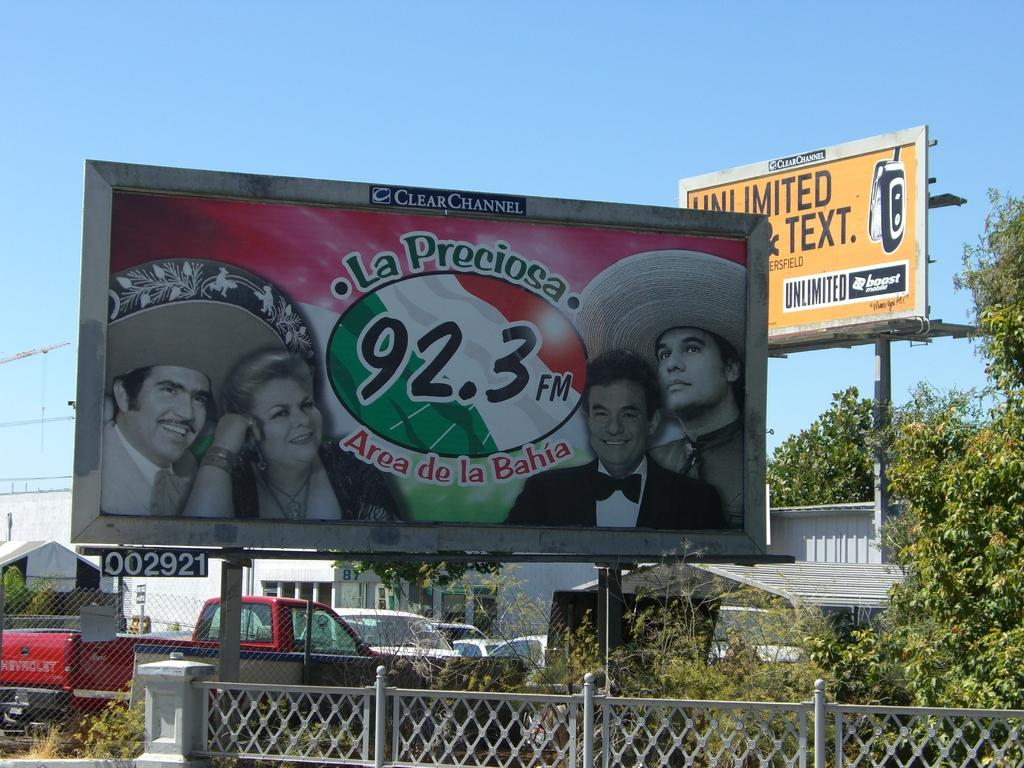Provide a one-sentence caption for the provided image. A billboard advertises the radio station LA Preciosa, 92.3 FM, Area de la Baja with another billboard for unlimited talk and text in the background. 